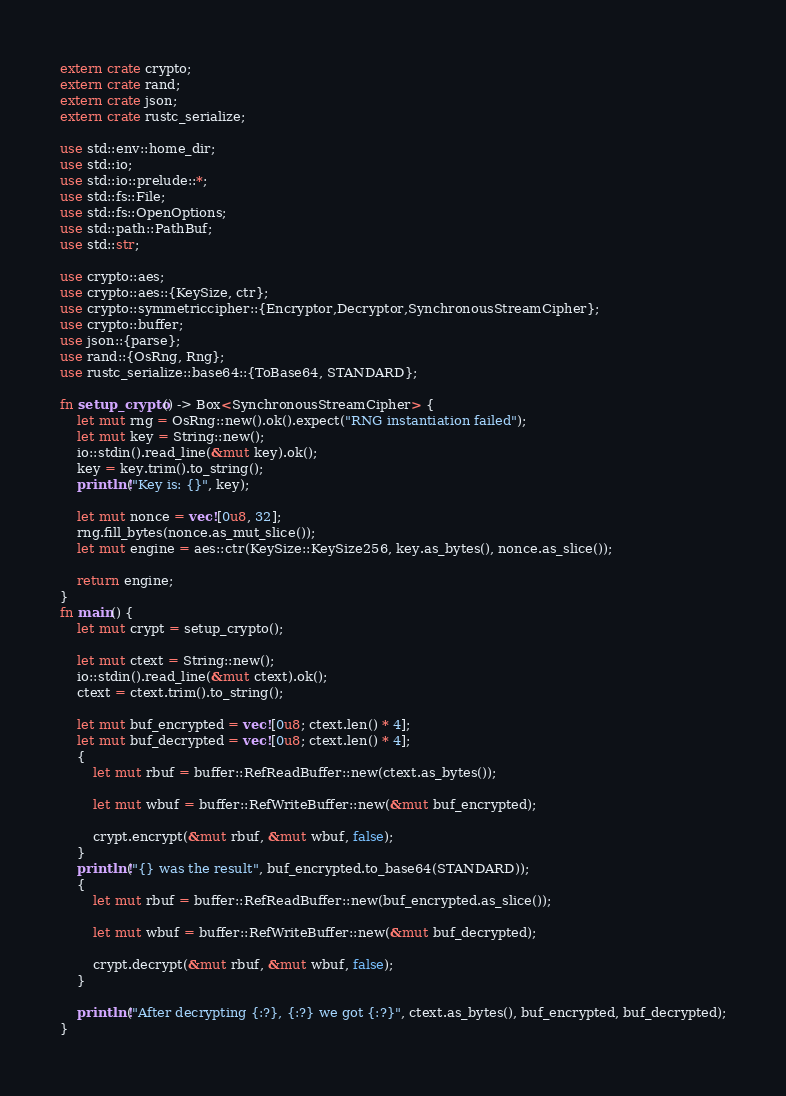<code> <loc_0><loc_0><loc_500><loc_500><_Rust_>extern crate crypto;
extern crate rand;
extern crate json;
extern crate rustc_serialize;

use std::env::home_dir;
use std::io;
use std::io::prelude::*;
use std::fs::File;
use std::fs::OpenOptions;
use std::path::PathBuf;
use std::str;

use crypto::aes;
use crypto::aes::{KeySize, ctr};
use crypto::symmetriccipher::{Encryptor,Decryptor,SynchronousStreamCipher};
use crypto::buffer;
use json::{parse};
use rand::{OsRng, Rng};
use rustc_serialize::base64::{ToBase64, STANDARD};

fn setup_crypto() -> Box<SynchronousStreamCipher> {
    let mut rng = OsRng::new().ok().expect("RNG instantiation failed");
    let mut key = String::new();
    io::stdin().read_line(&mut key).ok();
    key = key.trim().to_string();
    println!("Key is: {}", key);

    let mut nonce = vec![0u8, 32];
    rng.fill_bytes(nonce.as_mut_slice());
    let mut engine = aes::ctr(KeySize::KeySize256, key.as_bytes(), nonce.as_slice());

    return engine;
}
fn main() {
    let mut crypt = setup_crypto();
    
    let mut ctext = String::new();
    io::stdin().read_line(&mut ctext).ok();
    ctext = ctext.trim().to_string();

    let mut buf_encrypted = vec![0u8; ctext.len() * 4];
    let mut buf_decrypted = vec![0u8; ctext.len() * 4];
    {
        let mut rbuf = buffer::RefReadBuffer::new(ctext.as_bytes());

        let mut wbuf = buffer::RefWriteBuffer::new(&mut buf_encrypted);

        crypt.encrypt(&mut rbuf, &mut wbuf, false);
    }
    println!("{} was the result", buf_encrypted.to_base64(STANDARD));
    {
        let mut rbuf = buffer::RefReadBuffer::new(buf_encrypted.as_slice());

        let mut wbuf = buffer::RefWriteBuffer::new(&mut buf_decrypted);

        crypt.decrypt(&mut rbuf, &mut wbuf, false);
    }

    println!("After decrypting {:?}, {:?} we got {:?}", ctext.as_bytes(), buf_encrypted, buf_decrypted);
}
</code> 